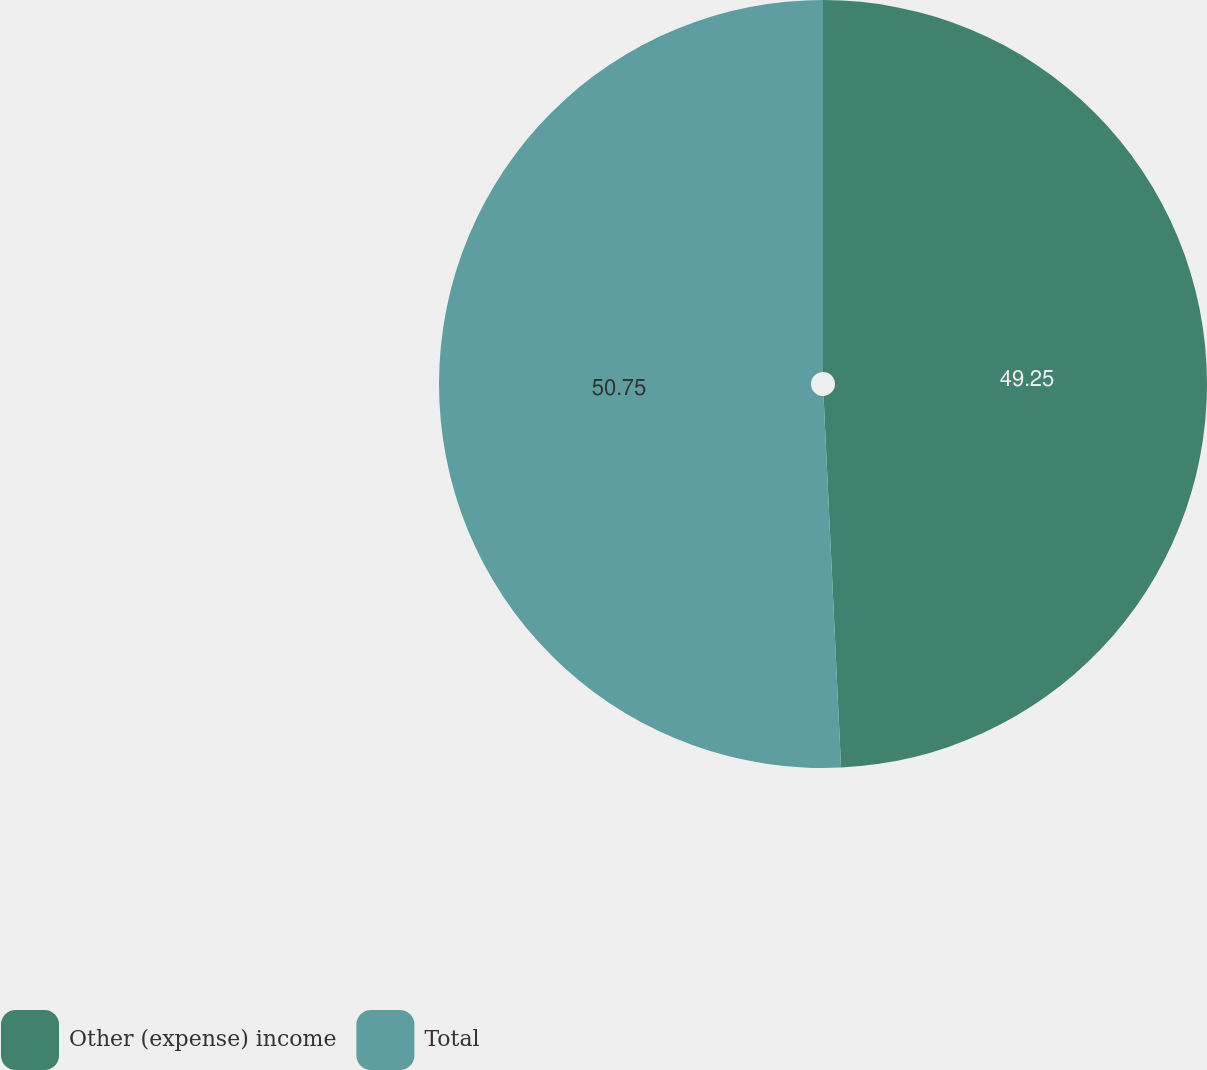Convert chart. <chart><loc_0><loc_0><loc_500><loc_500><pie_chart><fcel>Other (expense) income<fcel>Total<nl><fcel>49.25%<fcel>50.75%<nl></chart> 